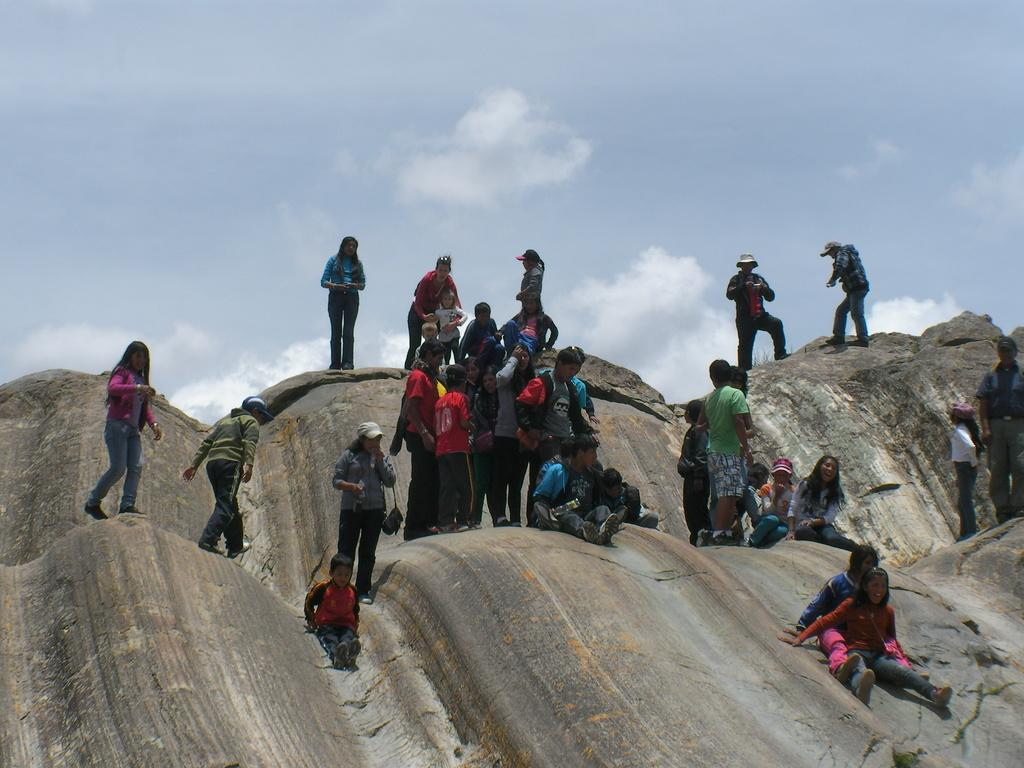What types of people are in the image? There are persons in the image. Can you identify any specific group of people in the image? Yes, there are kids in the image. Where are the persons and kids located in the image? The persons and kids are on a rock hill. What can be seen in the sky in the image? There are clouds visible in the sky. What type of market can be seen in the image? There is no market present in the image. What is the approval rating of the persons and kids in the image? There is no indication of approval ratings in the image, as it features people on a rock hill. 